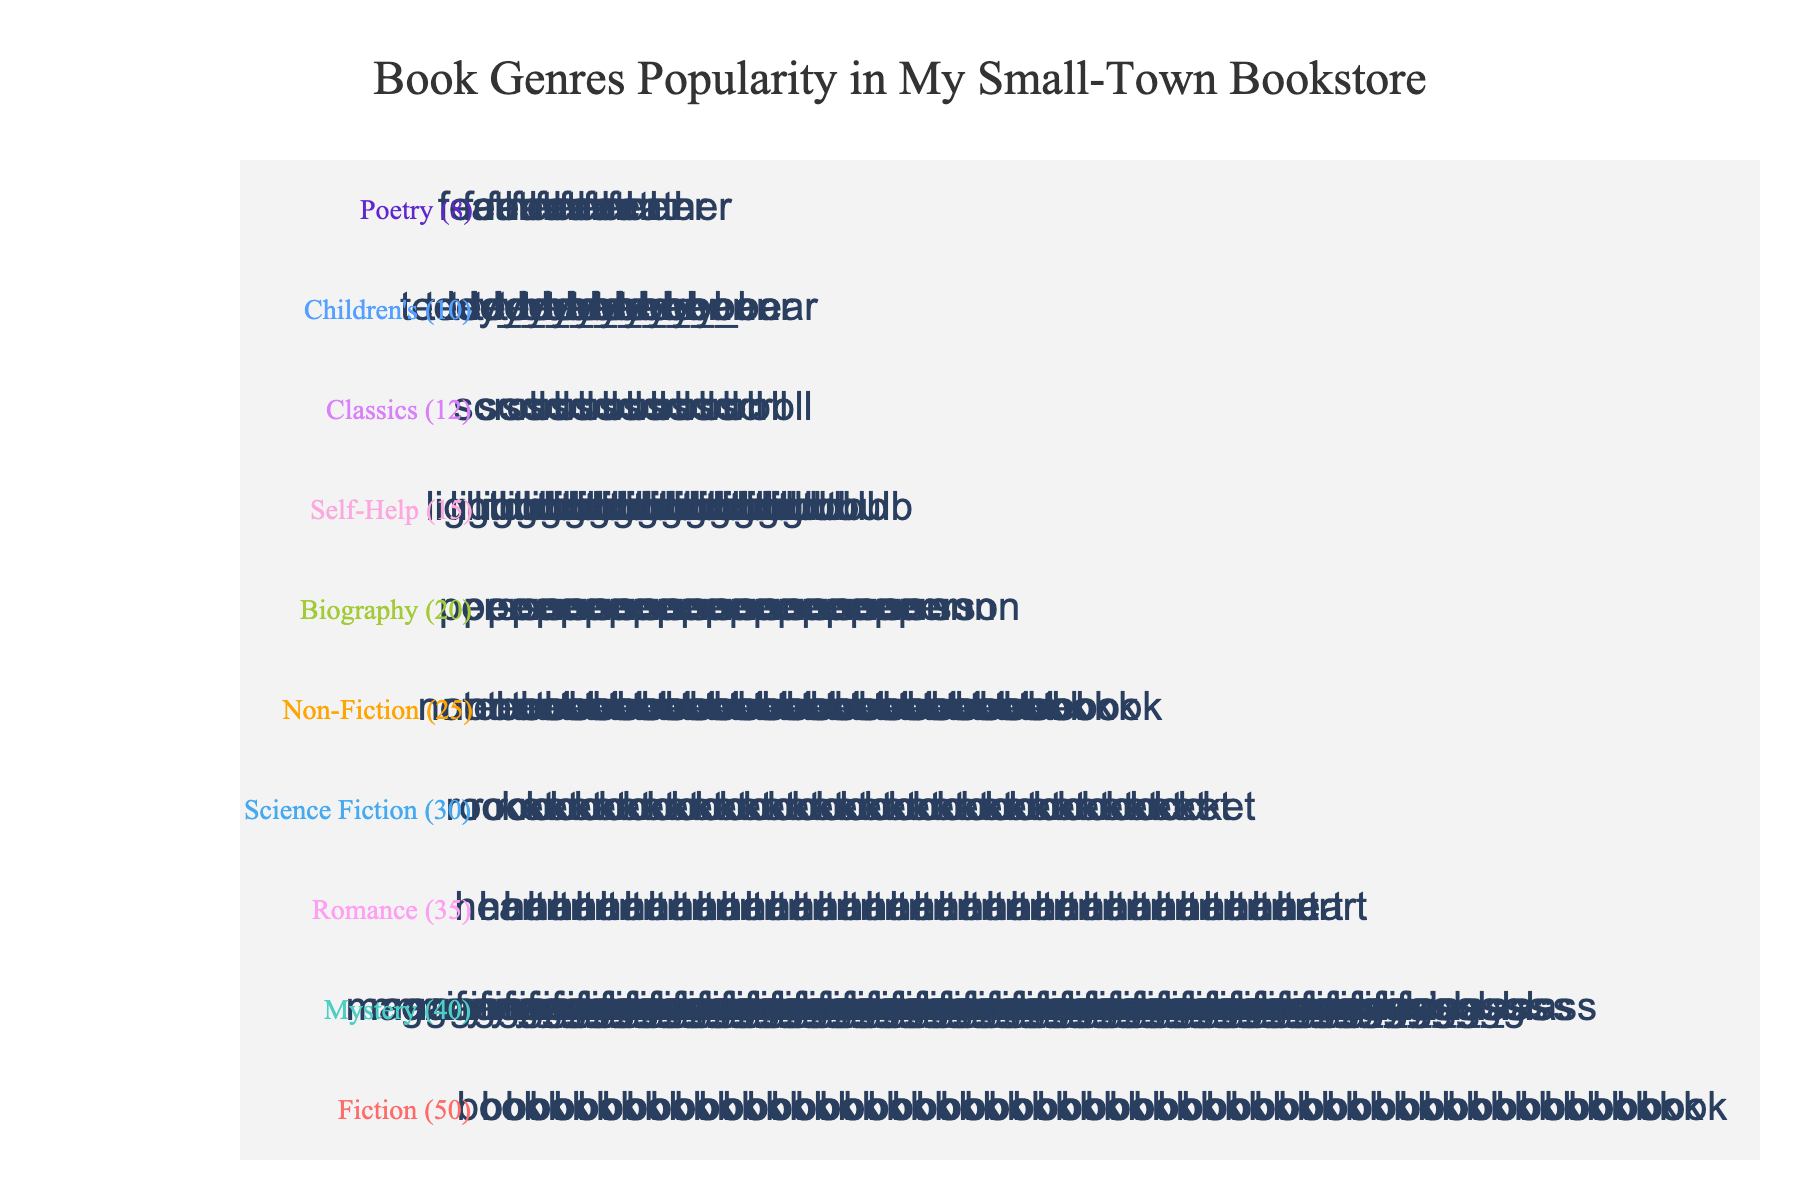How many genres are represented in the plot? There are 10 genres listed in the data provided (Fiction, Mystery, Romance, Science Fiction, Non-Fiction, Biography, Self-Help, Classics, Children's, Poetry).
Answer: 10 Which genre has the highest count of books sold? The data shows the counts for each genre, and Fiction has the highest count of 50.
Answer: Fiction How many more Romantic books were sold compared to Science Fiction books? The Romance genre has 35 books sold, and the Science Fiction genre has 30 books sold. The difference in their counts is 35 - 30.
Answer: 5 Which genre has the fewest books sold? According to the data, Poetry has the fewest books sold with a count of 8.
Answer: Poetry What is the total number of books sold across all genres? Adding the counts for all genres: 50 (Fiction) + 40 (Mystery) + 35 (Romance) + 30 (Sci-Fi) + 25 (Non-Fiction) + 20 (Biography) + 15 (Self-Help) + 12 (Classics) + 10 (Children's) + 8 (Poetry) = 245
Answer: 245 How does the popularity of Non-Fiction books compare to that of Fiction books? Non-Fiction has 25 books sold, while Fiction has 50. Comparatively, Fiction is twice as popular as Non-Fiction.
Answer: Fiction is twice as popular Which two genres combined have the same number of books sold as Mystery? Romance (35) and Poetry (8) combined have 43 books sold, which is close to Mystery's 40. This might not be exact, but no other combination reaches exactly 40.
Answer: Romance and Poetry What is the average number of books sold per genre? To find the average, divide the total number of books sold (245) by the number of genres (10). 245 / 10 = 24.5
Answer: 24.5 Are there more books sold in the Romance or Biography genre? Romance has 35 books sold, while Biography has 20 books sold. Romance has more books sold.
Answer: Romance If you add the counts of Poetry and Children's books, how does their total compare to the count of Self-Help books? Poetry has 8 and Children's has 10. Adding these gives 8 + 10 = 18, which is more than Self-Help's count of 15.
Answer: More 